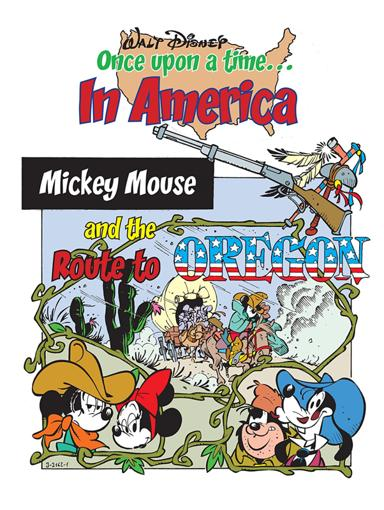Can you describe the setting and the activities depicted involving the Disney characters in this image? The image showcases a lively and imaginative depiction of a journey through America to Oregon. Mickey Mouse, dressed as a pioneer, is leading a wagon pulled by Pluto, while Minnie Mouse and Goofy engage with various aspects of traditional American frontier life, such as exploring and setting up a homestead. 